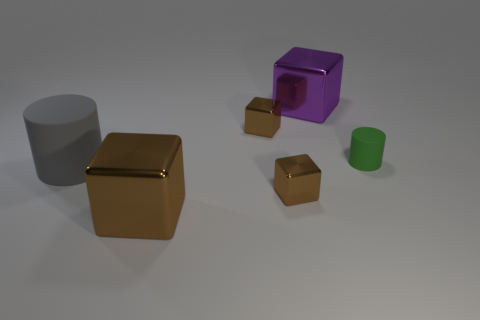Subtract all brown blocks. How many were subtracted if there are1brown blocks left? 2 Subtract all brown metal cubes. How many cubes are left? 1 Add 1 big gray things. How many objects exist? 7 Subtract all purple blocks. How many blocks are left? 3 Subtract 2 cylinders. How many cylinders are left? 0 Add 3 big metal things. How many big metal things are left? 5 Add 3 purple things. How many purple things exist? 4 Subtract 0 gray spheres. How many objects are left? 6 Subtract all cubes. How many objects are left? 2 Subtract all brown cylinders. Subtract all green blocks. How many cylinders are left? 2 